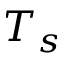Convert formula to latex. <formula><loc_0><loc_0><loc_500><loc_500>T _ { s }</formula> 